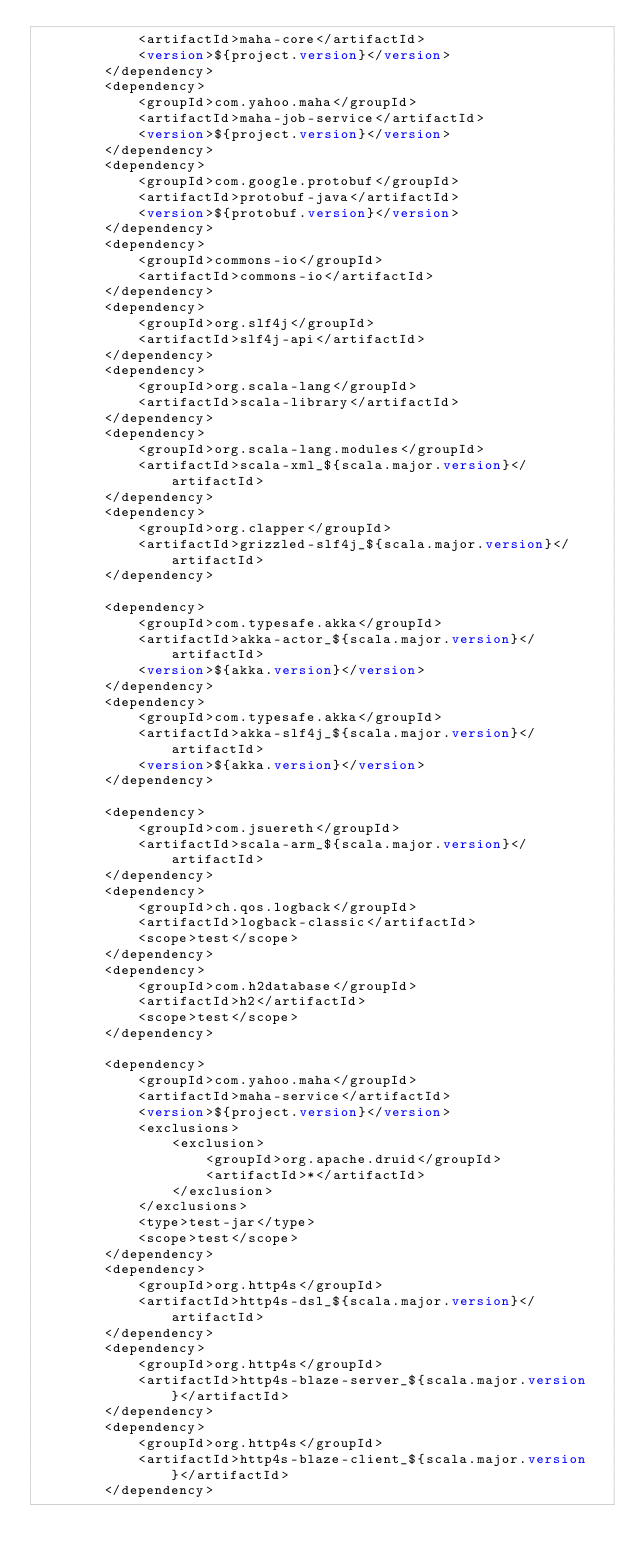<code> <loc_0><loc_0><loc_500><loc_500><_XML_>            <artifactId>maha-core</artifactId>
            <version>${project.version}</version>
        </dependency>
        <dependency>
            <groupId>com.yahoo.maha</groupId>
            <artifactId>maha-job-service</artifactId>
            <version>${project.version}</version>
        </dependency>
        <dependency>
            <groupId>com.google.protobuf</groupId>
            <artifactId>protobuf-java</artifactId>
            <version>${protobuf.version}</version>
        </dependency>
        <dependency>
            <groupId>commons-io</groupId>
            <artifactId>commons-io</artifactId>
        </dependency>
        <dependency>
            <groupId>org.slf4j</groupId>
            <artifactId>slf4j-api</artifactId>
        </dependency>
        <dependency>
            <groupId>org.scala-lang</groupId>
            <artifactId>scala-library</artifactId>
        </dependency>
        <dependency>
            <groupId>org.scala-lang.modules</groupId>
            <artifactId>scala-xml_${scala.major.version}</artifactId>
        </dependency>
        <dependency>
            <groupId>org.clapper</groupId>
            <artifactId>grizzled-slf4j_${scala.major.version}</artifactId>
        </dependency>

        <dependency>
            <groupId>com.typesafe.akka</groupId>
            <artifactId>akka-actor_${scala.major.version}</artifactId>
            <version>${akka.version}</version>
        </dependency>
        <dependency>
            <groupId>com.typesafe.akka</groupId>
            <artifactId>akka-slf4j_${scala.major.version}</artifactId>
            <version>${akka.version}</version>
        </dependency>

        <dependency>
            <groupId>com.jsuereth</groupId>
            <artifactId>scala-arm_${scala.major.version}</artifactId>
        </dependency>
        <dependency>
            <groupId>ch.qos.logback</groupId>
            <artifactId>logback-classic</artifactId>
            <scope>test</scope>
        </dependency>
        <dependency>
            <groupId>com.h2database</groupId>
            <artifactId>h2</artifactId>
            <scope>test</scope>
        </dependency>

        <dependency>
            <groupId>com.yahoo.maha</groupId>
            <artifactId>maha-service</artifactId>
            <version>${project.version}</version>
            <exclusions>
                <exclusion>
                    <groupId>org.apache.druid</groupId>
                    <artifactId>*</artifactId>
                </exclusion>
            </exclusions>
            <type>test-jar</type>
            <scope>test</scope>
        </dependency>
        <dependency>
            <groupId>org.http4s</groupId>
            <artifactId>http4s-dsl_${scala.major.version}</artifactId>
        </dependency>
        <dependency>
            <groupId>org.http4s</groupId>
            <artifactId>http4s-blaze-server_${scala.major.version}</artifactId>
        </dependency>
        <dependency>
            <groupId>org.http4s</groupId>
            <artifactId>http4s-blaze-client_${scala.major.version}</artifactId>
        </dependency>
</code> 